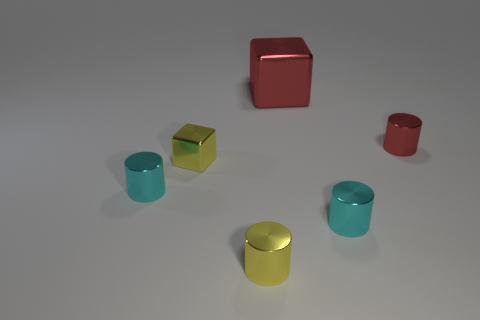Add 1 large things. How many objects exist? 7 Subtract all cylinders. How many objects are left? 2 Add 5 small yellow metal cubes. How many small yellow metal cubes exist? 6 Subtract 0 brown balls. How many objects are left? 6 Subtract all tiny yellow cubes. Subtract all big green balls. How many objects are left? 5 Add 4 yellow cubes. How many yellow cubes are left? 5 